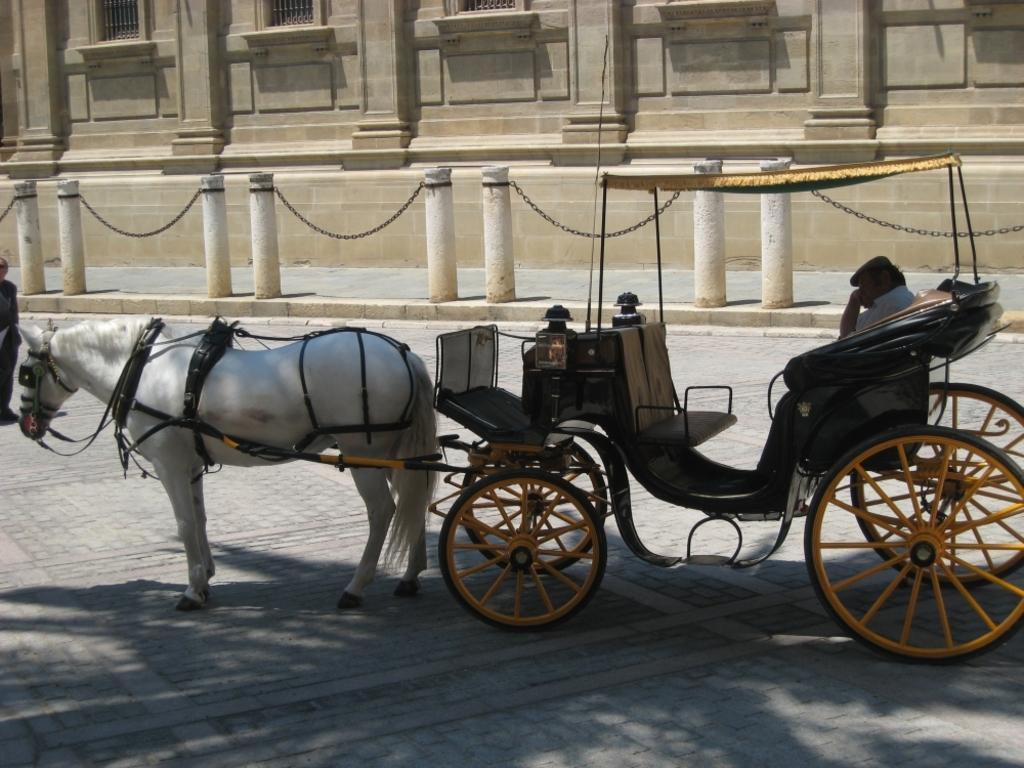Could you give a brief overview of what you see in this image? In this image in center there is a horse car and there is a person sitting inside it. In the background there is a fence and there is a building. On the left side there is a person standing. 